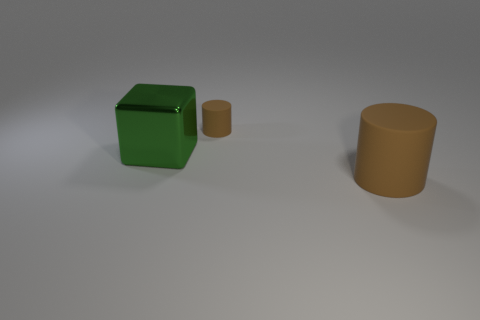Add 2 big blocks. How many objects exist? 5 Subtract all cylinders. How many objects are left? 1 Add 3 cylinders. How many cylinders exist? 5 Subtract 0 yellow cylinders. How many objects are left? 3 Subtract all large brown matte cylinders. Subtract all brown cylinders. How many objects are left? 0 Add 3 large green shiny things. How many large green shiny things are left? 4 